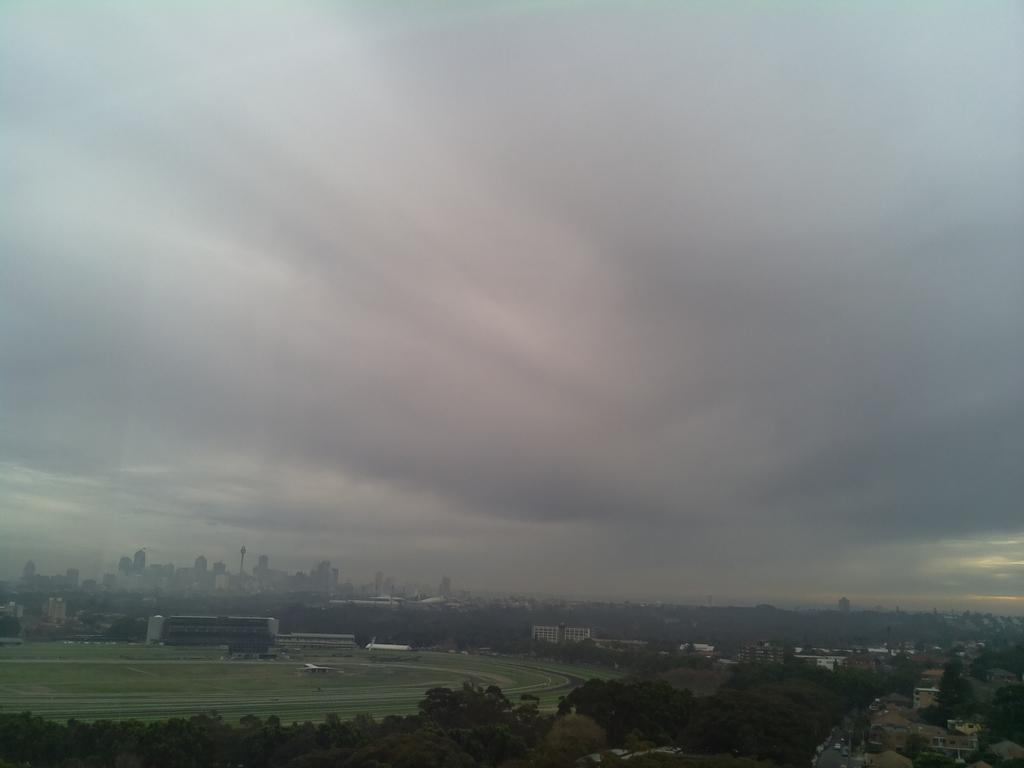What type of natural elements can be seen in the image? There are trees in the image. What type of man-made structures are visible in the image? There are buildings in the image. What is visible in the background of the image? The sky is visible in the background of the image. What can be seen in the sky? Clouds are present in the sky. Can you tell me how many cords are hanging from the trees in the image? There are no cords hanging from the trees in the image; only trees, buildings, and clouds are present. What type of men can be seen interacting with the clams in the image? There are no men or clams present in the image. 